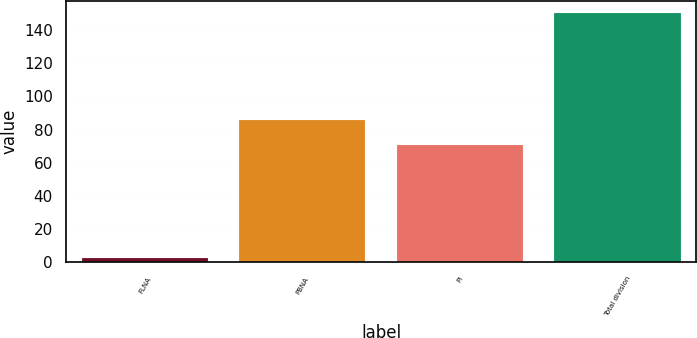Convert chart to OTSL. <chart><loc_0><loc_0><loc_500><loc_500><bar_chart><fcel>FLNA<fcel>PBNA<fcel>PI<fcel>Total division<nl><fcel>3<fcel>85.7<fcel>71<fcel>150<nl></chart> 